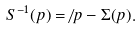<formula> <loc_0><loc_0><loc_500><loc_500>S ^ { - 1 } ( p ) = \not \, p - \Sigma ( p ) .</formula> 